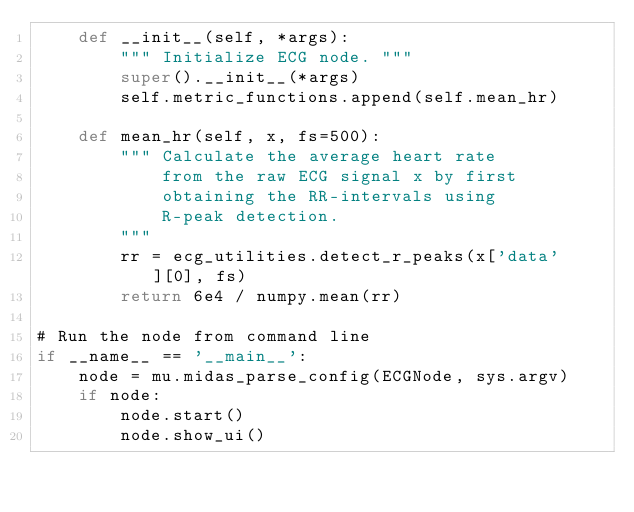<code> <loc_0><loc_0><loc_500><loc_500><_Python_>    def __init__(self, *args):
        """ Initialize ECG node. """
        super().__init__(*args)
        self.metric_functions.append(self.mean_hr)

    def mean_hr(self, x, fs=500):
        """ Calculate the average heart rate 
            from the raw ECG signal x by first
            obtaining the RR-intervals using
            R-peak detection.
        """
        rr = ecg_utilities.detect_r_peaks(x['data'][0], fs)
        return 6e4 / numpy.mean(rr)

# Run the node from command line
if __name__ == '__main__':
    node = mu.midas_parse_config(ECGNode, sys.argv)
    if node:
        node.start()
        node.show_ui()
</code> 